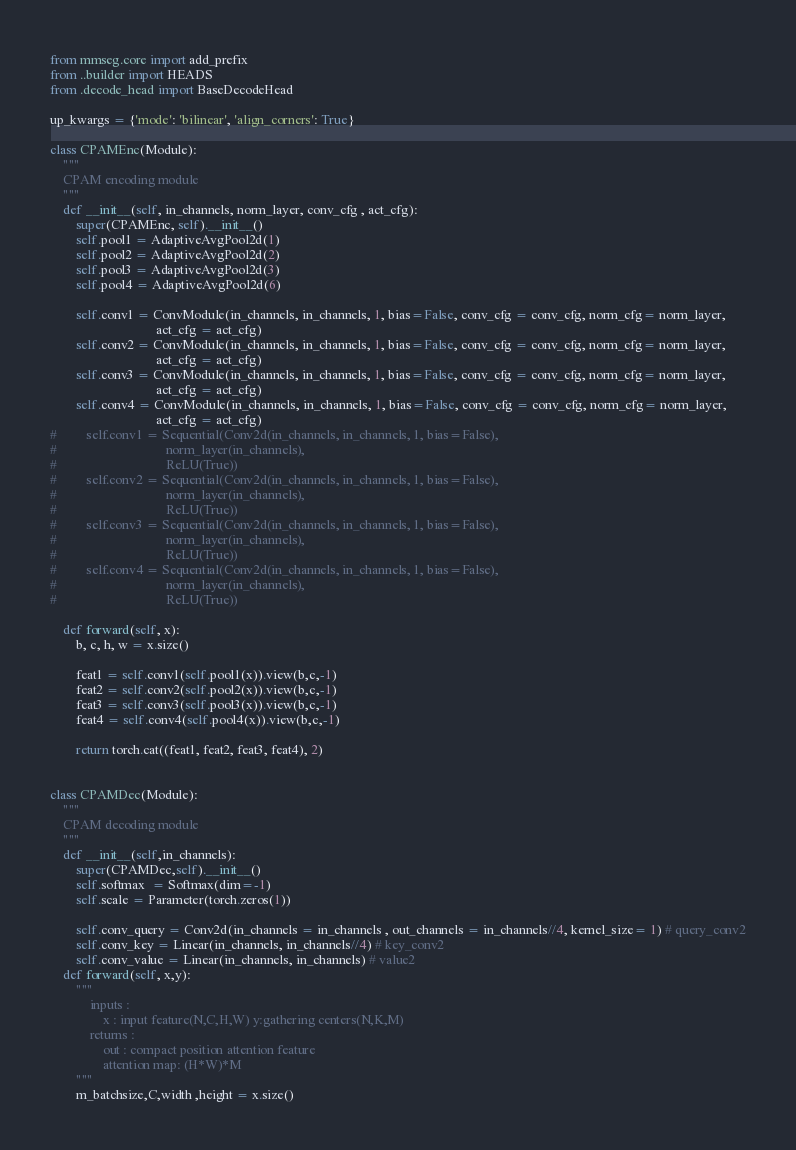Convert code to text. <code><loc_0><loc_0><loc_500><loc_500><_Python_>
from mmseg.core import add_prefix
from ..builder import HEADS
from .decode_head import BaseDecodeHead

up_kwargs = {'mode': 'bilinear', 'align_corners': True}

class CPAMEnc(Module):
    """
    CPAM encoding module
    """
    def __init__(self, in_channels, norm_layer, conv_cfg , act_cfg):
        super(CPAMEnc, self).__init__()
        self.pool1 = AdaptiveAvgPool2d(1)
        self.pool2 = AdaptiveAvgPool2d(2)
        self.pool3 = AdaptiveAvgPool2d(3)
        self.pool4 = AdaptiveAvgPool2d(6)
        
        self.conv1 = ConvModule(in_channels, in_channels, 1, bias=False, conv_cfg = conv_cfg, norm_cfg= norm_layer, 
                                act_cfg = act_cfg)
        self.conv2 = ConvModule(in_channels, in_channels, 1, bias=False, conv_cfg = conv_cfg, norm_cfg= norm_layer, 
                                act_cfg = act_cfg)
        self.conv3 = ConvModule(in_channels, in_channels, 1, bias=False, conv_cfg = conv_cfg, norm_cfg= norm_layer, 
                                act_cfg = act_cfg)
        self.conv4 = ConvModule(in_channels, in_channels, 1, bias=False, conv_cfg = conv_cfg, norm_cfg= norm_layer, 
                                act_cfg = act_cfg)
#         self.conv1 = Sequential(Conv2d(in_channels, in_channels, 1, bias=False),
#                                 norm_layer(in_channels),
#                                 ReLU(True))
#         self.conv2 = Sequential(Conv2d(in_channels, in_channels, 1, bias=False),
#                                 norm_layer(in_channels),
#                                 ReLU(True))
#         self.conv3 = Sequential(Conv2d(in_channels, in_channels, 1, bias=False),
#                                 norm_layer(in_channels),
#                                 ReLU(True))
#         self.conv4 = Sequential(Conv2d(in_channels, in_channels, 1, bias=False),
#                                 norm_layer(in_channels),
#                                 ReLU(True))

    def forward(self, x):
        b, c, h, w = x.size()
        
        feat1 = self.conv1(self.pool1(x)).view(b,c,-1)
        feat2 = self.conv2(self.pool2(x)).view(b,c,-1)
        feat3 = self.conv3(self.pool3(x)).view(b,c,-1)
        feat4 = self.conv4(self.pool4(x)).view(b,c,-1)
        
        return torch.cat((feat1, feat2, feat3, feat4), 2)


class CPAMDec(Module):
    """
    CPAM decoding module
    """
    def __init__(self,in_channels):
        super(CPAMDec,self).__init__()
        self.softmax  = Softmax(dim=-1)
        self.scale = Parameter(torch.zeros(1))

        self.conv_query = Conv2d(in_channels = in_channels , out_channels = in_channels//4, kernel_size= 1) # query_conv2
        self.conv_key = Linear(in_channels, in_channels//4) # key_conv2
        self.conv_value = Linear(in_channels, in_channels) # value2
    def forward(self, x,y):
        """
            inputs :
                x : input feature(N,C,H,W) y:gathering centers(N,K,M)
            returns :
                out : compact position attention feature
                attention map: (H*W)*M
        """
        m_batchsize,C,width ,height = x.size()</code> 